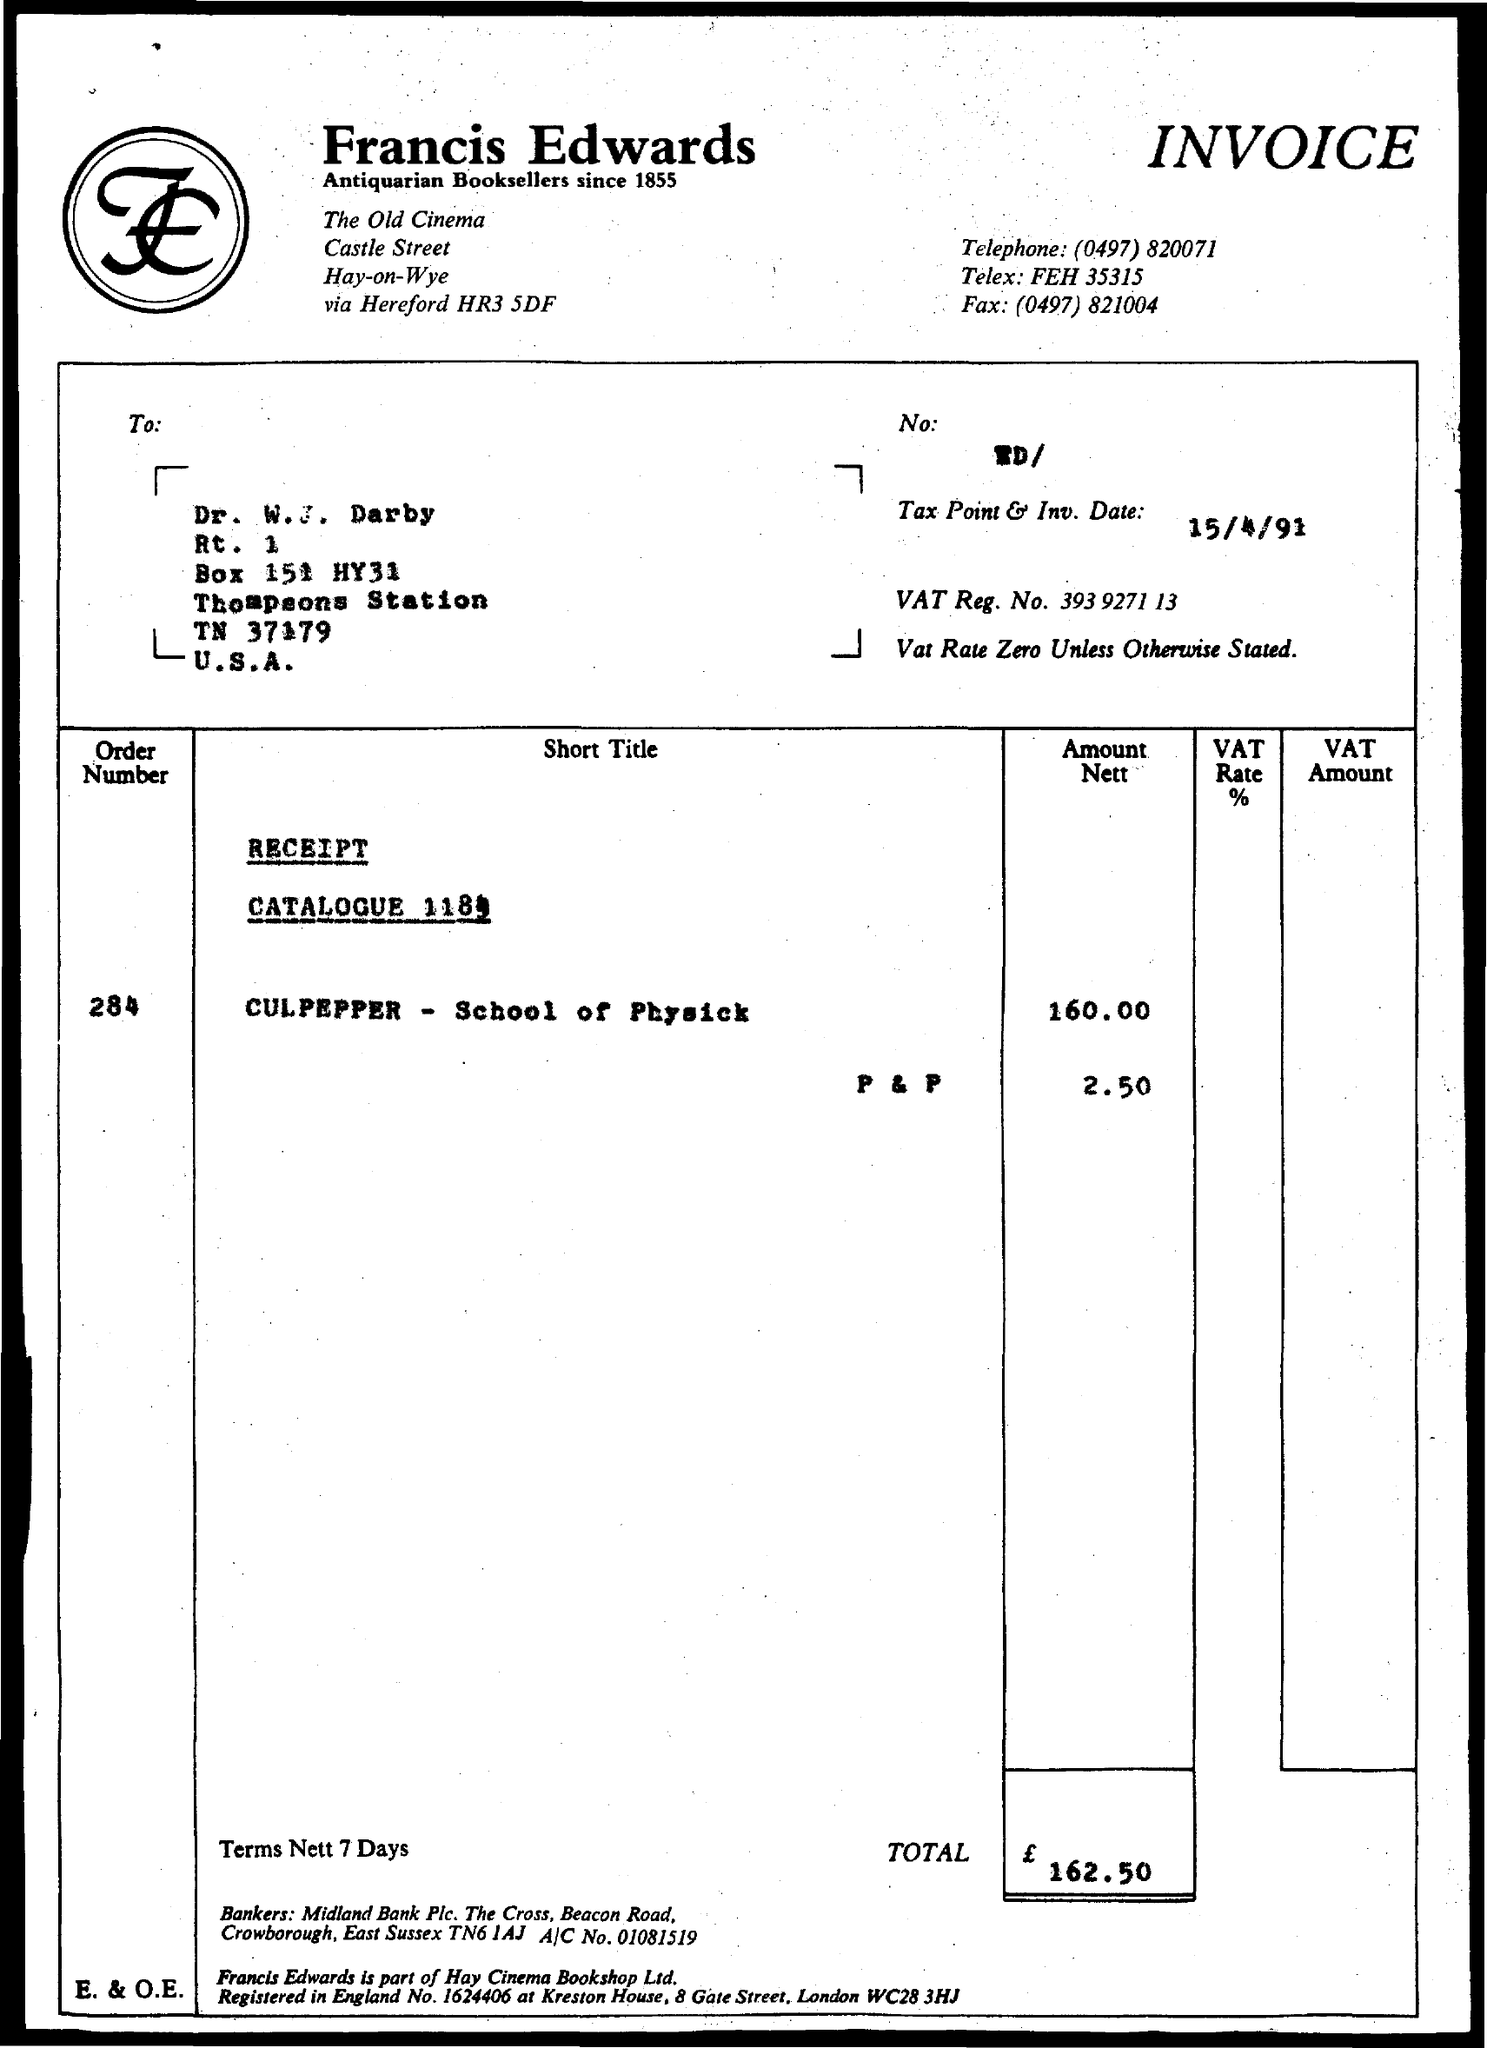Mention a couple of crucial points in this snapshot. Please provide the order number, which is 284. The telephone number of the shop is (04) 978 20071. The VAT registration number is 393 9271 13... What is the tax point and investment date? 15/4/91... 